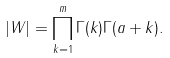<formula> <loc_0><loc_0><loc_500><loc_500>| W | = \prod _ { k = 1 } ^ { m } \Gamma ( k ) \Gamma ( a + k ) .</formula> 